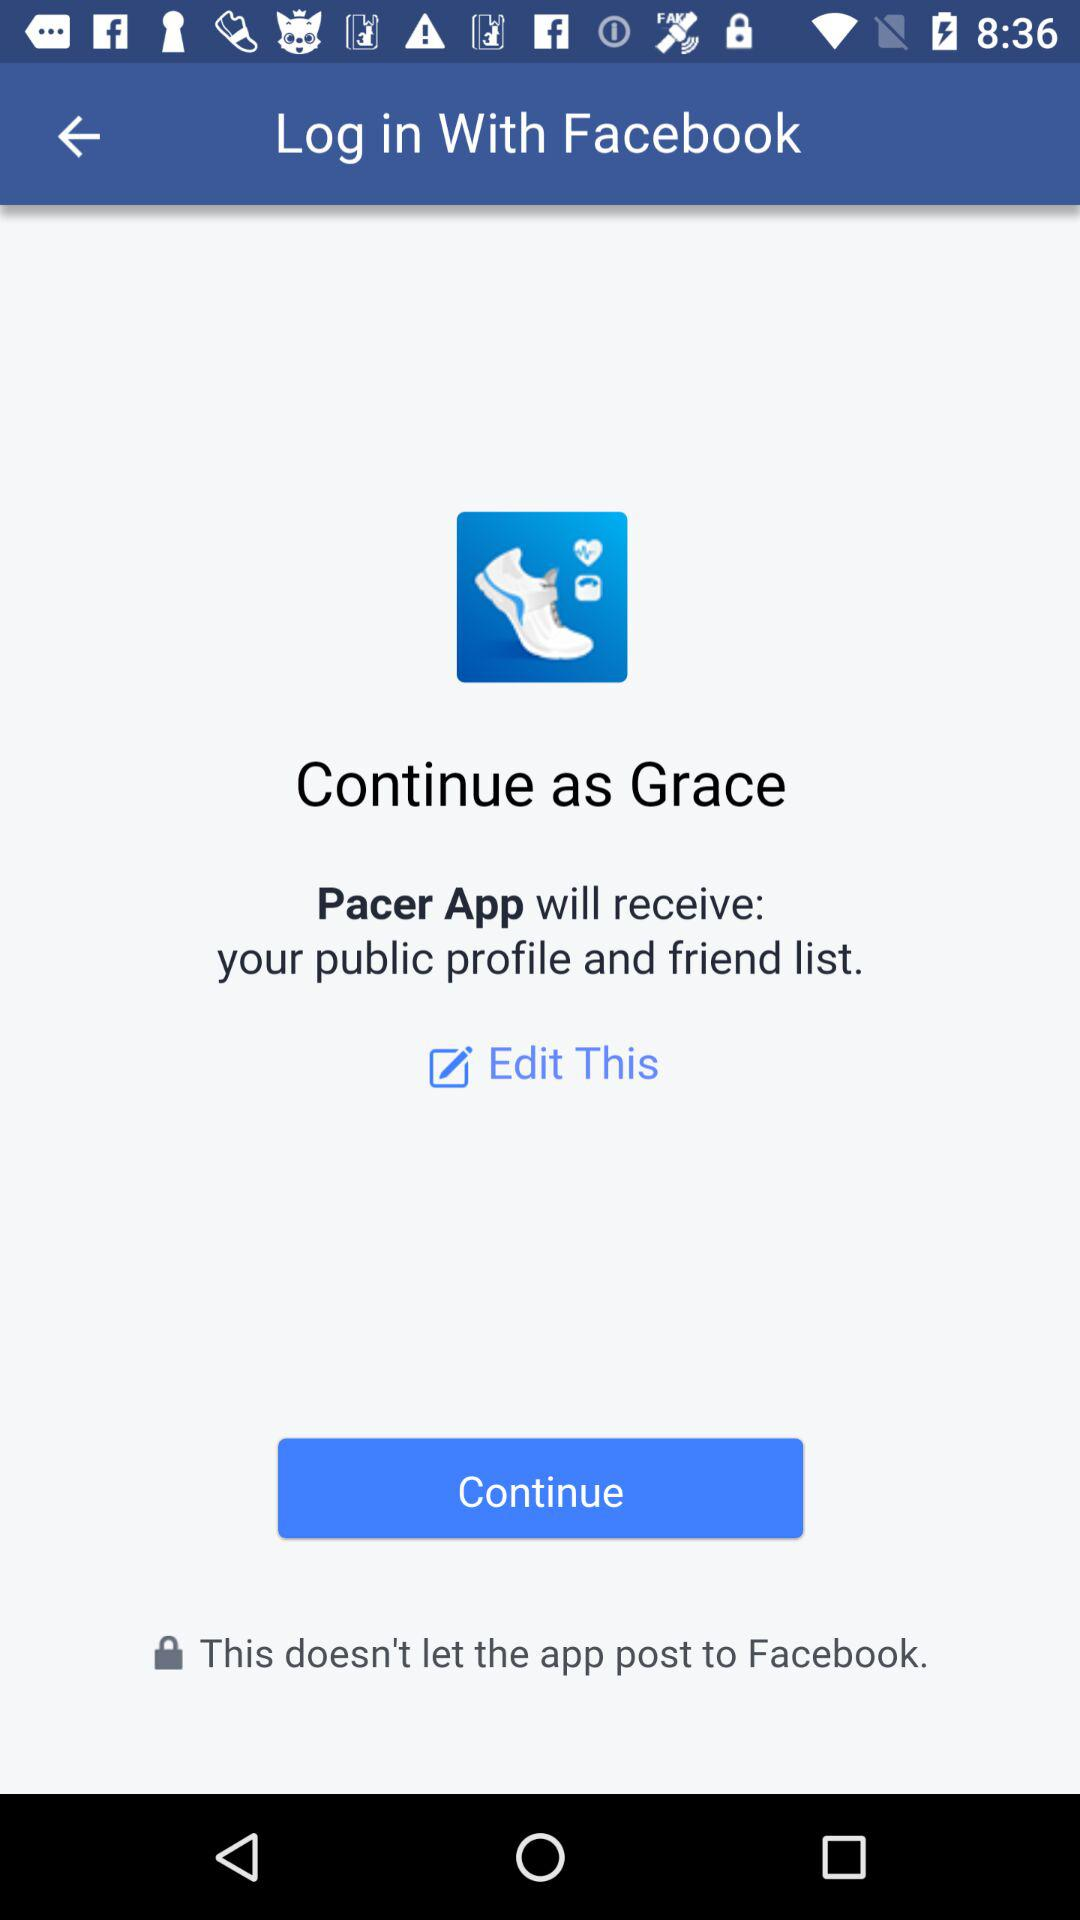What application is asking for permission? The application asking for permission is "Pacer App". 